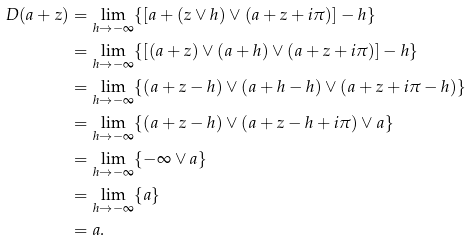Convert formula to latex. <formula><loc_0><loc_0><loc_500><loc_500>D ( a + z ) & = \lim _ { h \rightarrow - \infty } \{ [ a + ( z \vee h ) \vee ( a + z + i \pi ) ] - h \} \\ & = \lim _ { h \rightarrow - \infty } \{ [ ( a + z ) \vee ( a + h ) \vee ( a + z + i \pi ) ] - h \} \\ & = \lim _ { h \rightarrow - \infty } \{ ( a + z - h ) \vee ( a + h - h ) \vee ( a + z + i \pi - h ) \} \\ & = \lim _ { h \rightarrow - \infty } \{ ( a + z - h ) \vee ( a + z - h + i \pi ) \vee a \} \\ & = \lim _ { h \rightarrow - \infty } \{ - \infty \vee a \} \\ & = \lim _ { h \rightarrow - \infty } \{ a \} \\ & = a .</formula> 